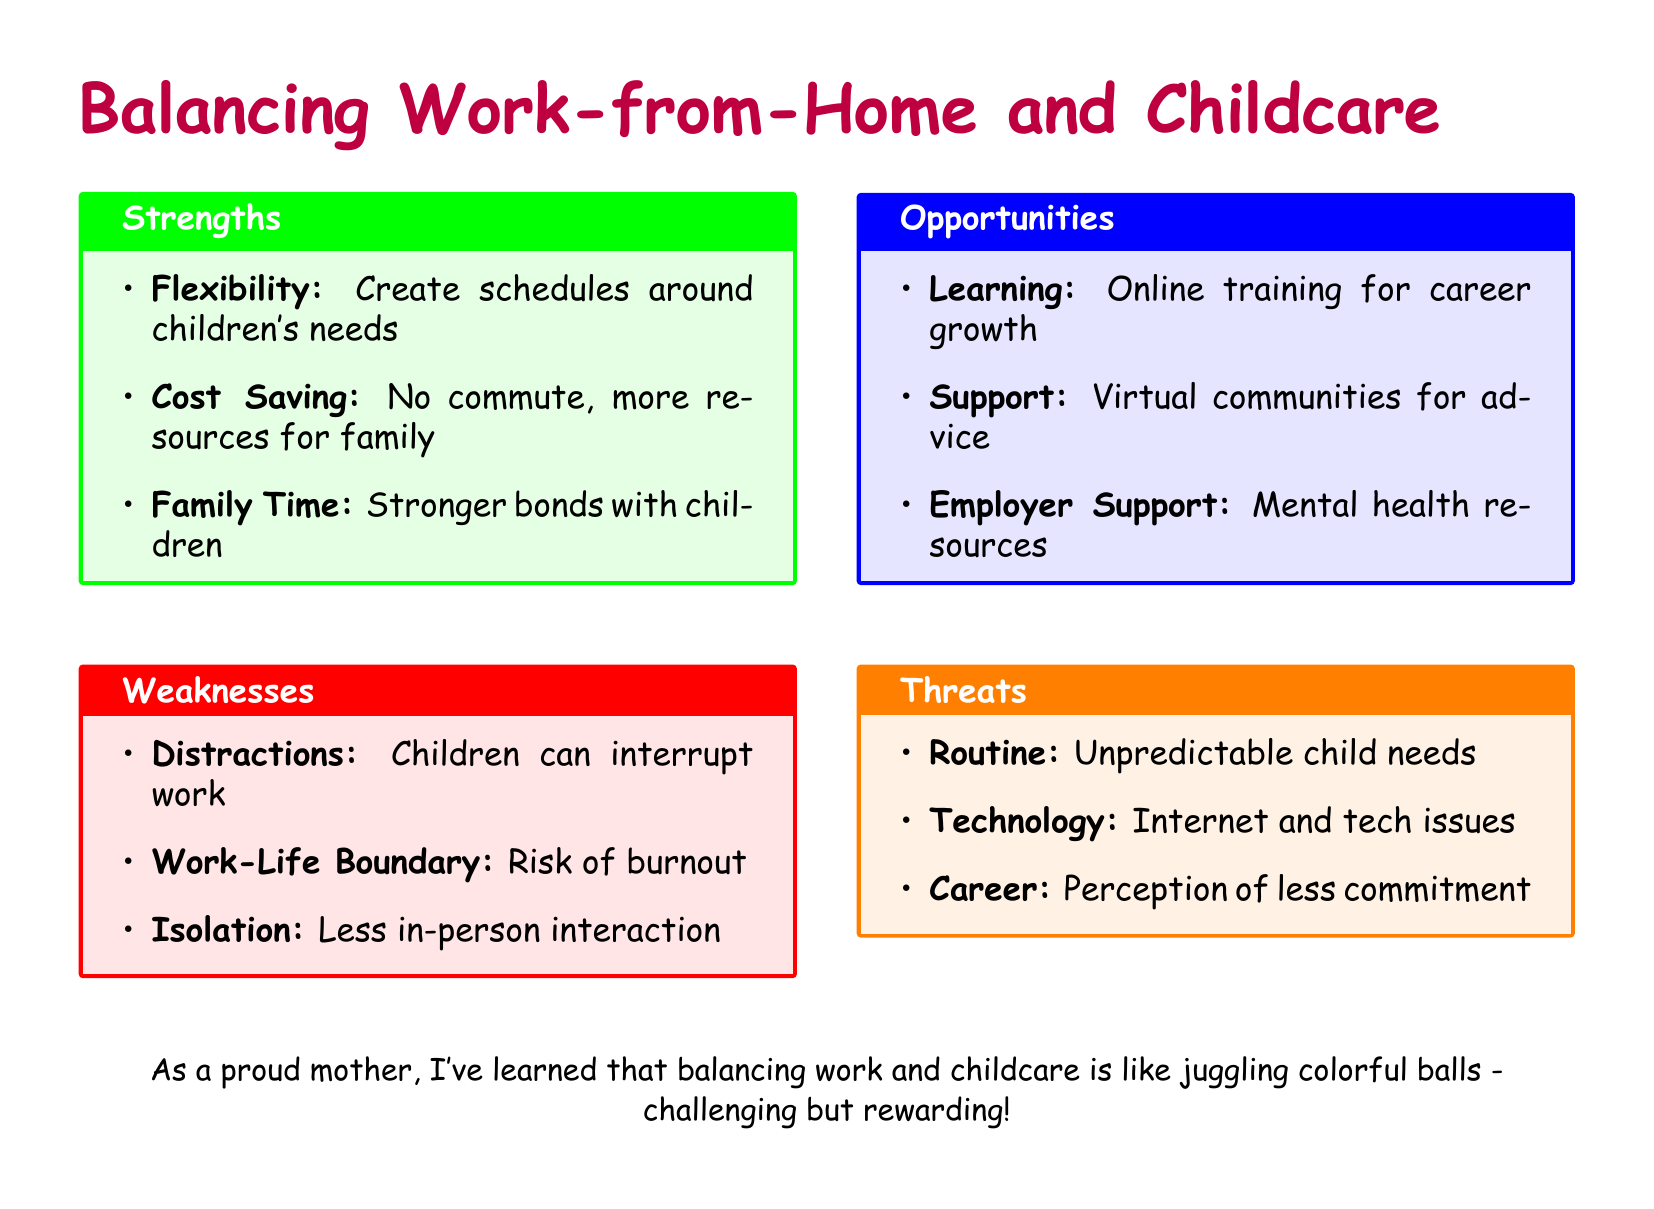What is a strength of balancing work-from-home and childcare? A strength mentioned in the document is the ability to create schedules around children's needs, indicating flexibility.
Answer: Flexibility What is one of the weaknesses associated with this balance? The document identifies distractions caused by children interrupting work as a weakness.
Answer: Distractions How many opportunities are listed in the document? The document lists three opportunities related to online training, virtual communities, and employer support.
Answer: Three What color represents threats in the SWOT analysis? The document shows that threats are represented by the color orange.
Answer: Orange What is a threat related to routine mentioned in the document? The document states that unpredictable child needs can pose a threat to the routine.
Answer: Unpredictable child needs What is the phrase used to describe the experience of balancing work and childcare? The document describes this experience metaphorically as juggling colorful balls.
Answer: Juggling colorful balls What is one way to support caregivers mentioned in the opportunities section? The document suggests that virtual communities can provide advice and support for caregivers.
Answer: Virtual communities What is the theme of the document? The document centers on the challenges and rewards of balancing work-from-home responsibilities and childcare.
Answer: Balancing work-from-home responsibilities and childcare 